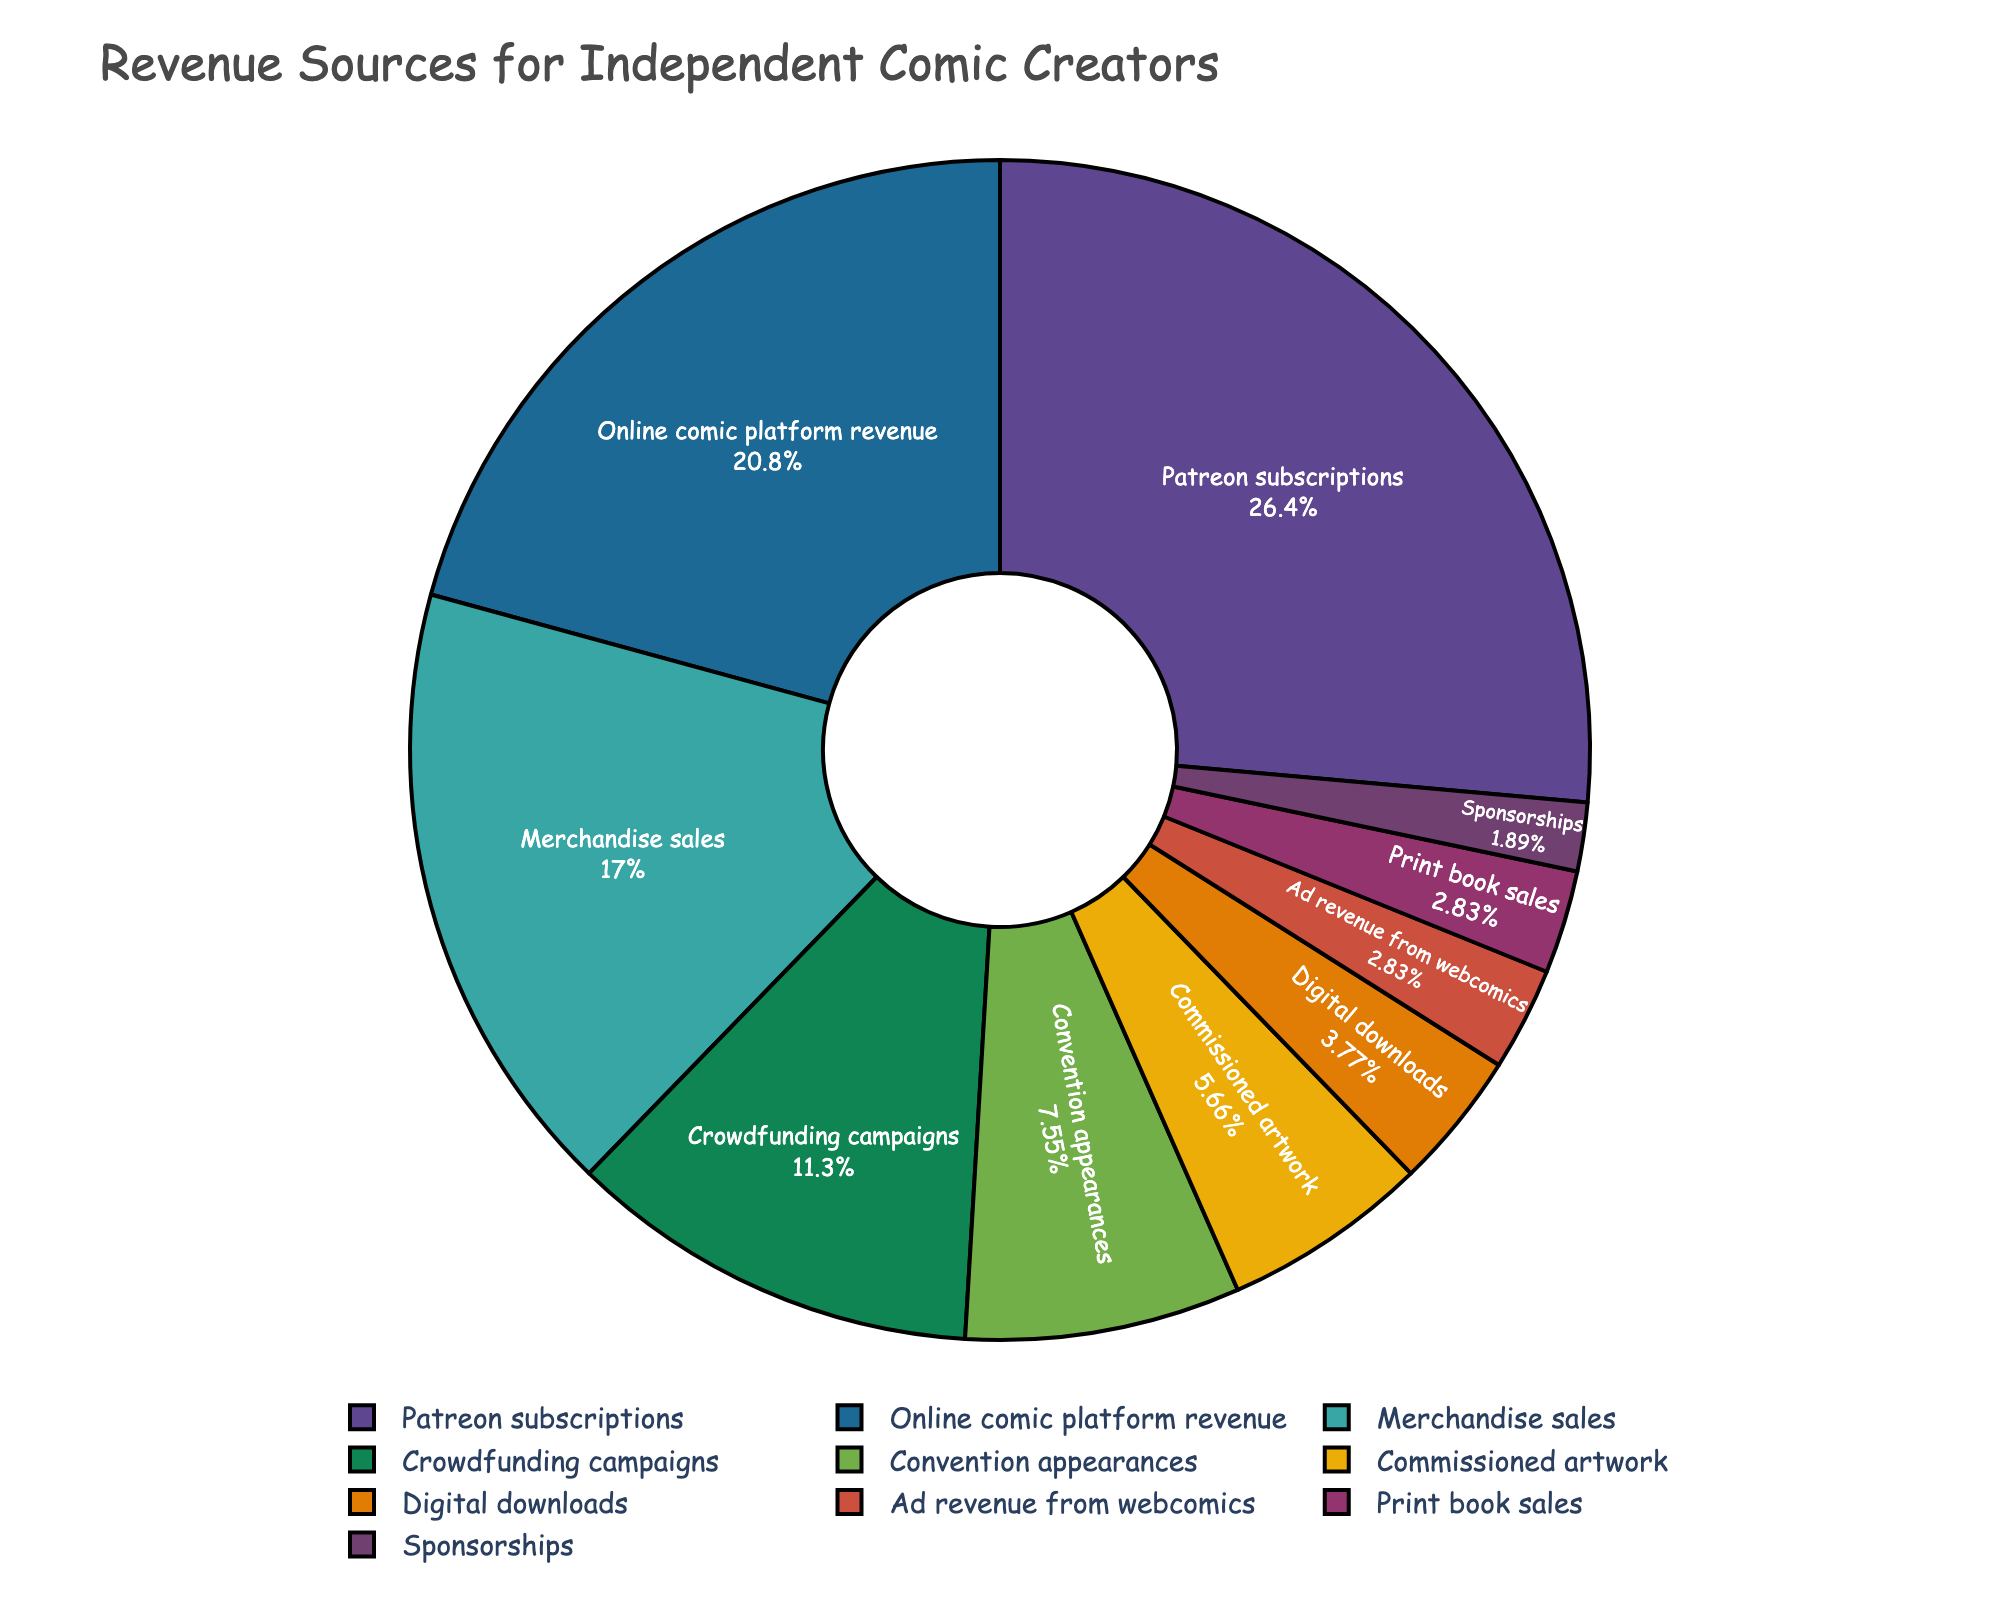What's the largest revenue source for independent comic creators? The largest revenue source is represented by the segment with the highest percentage. This is 'Patreon subscriptions' at 28%.
Answer: Patreon subscriptions What's the combined percentage of revenue from Merchandise sales and Crowdfunding campaigns? Merchandise sales contribute 18% and Crowdfunding campaigns add 12%. Adding these percentages gives 18% + 12% = 30%.
Answer: 30% Which revenue source is the smallest, and what percentage does it contribute? The smallest revenue source can be identified as the category with the smallest percentage, which is 'Sponsorships' at 2%.
Answer: Sponsorships, 2% Are Merchandise sales or Convention appearances a bigger source of revenue, and by how much? Merchandise sales are represented by 18% and Convention appearances by 8%. The difference is 18% - 8% = 10%.
Answer: Merchandise sales, 10% What is the difference in percentage between Online comic platform revenue and Print book sales? Online comic platform revenue accounts for 22% and Print book sales for 3%. The difference is 22% - 3% = 19%.
Answer: 19% How much do Commissioned artwork and Digital downloads contribute together? Commissioned artwork contributes 6% and Digital downloads contribute 4%. Adding these gives 6% + 4% = 10%.
Answer: 10% Which revenue source contributes more, Ad revenue from webcomics or Digital downloads, and what is the percentage difference? Ad revenue from webcomics contributes 3% while Digital downloads contribute 4%. The difference is 4% - 3% = 1%.
Answer: Digital downloads, 1% Which revenue sources together make up exactly half of the total revenue? Patreon subscriptions (28%) and Online comic platform revenue (22%) together make up 28% + 22% = 50%.
Answer: Patreon subscriptions and Online comic platform revenue Do Convention appearances bring in more revenue compared to both Digital downloads and Ad revenue from webcomics combined? Convention appearances bring in 8%, while Digital downloads (4%) and Ad revenue from webcomics (3%) combined bring in 4% + 3% = 7%. Convention appearances contribute 1% more.
Answer: Yes, 1% more What is the total percentage contributed by revenue sources less than 5% each? The sources less than 5% are Digital downloads (4%), Ad revenue from webcomics (3%), Print book sales (3%), and Sponsorships (2%). Summing these percentages gives 4% + 3% + 3% + 2% = 12%.
Answer: 12% 